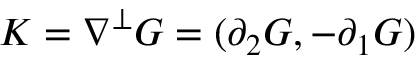Convert formula to latex. <formula><loc_0><loc_0><loc_500><loc_500>K = \nabla ^ { \bot } G = ( \partial _ { 2 } G , - \partial _ { 1 } G )</formula> 